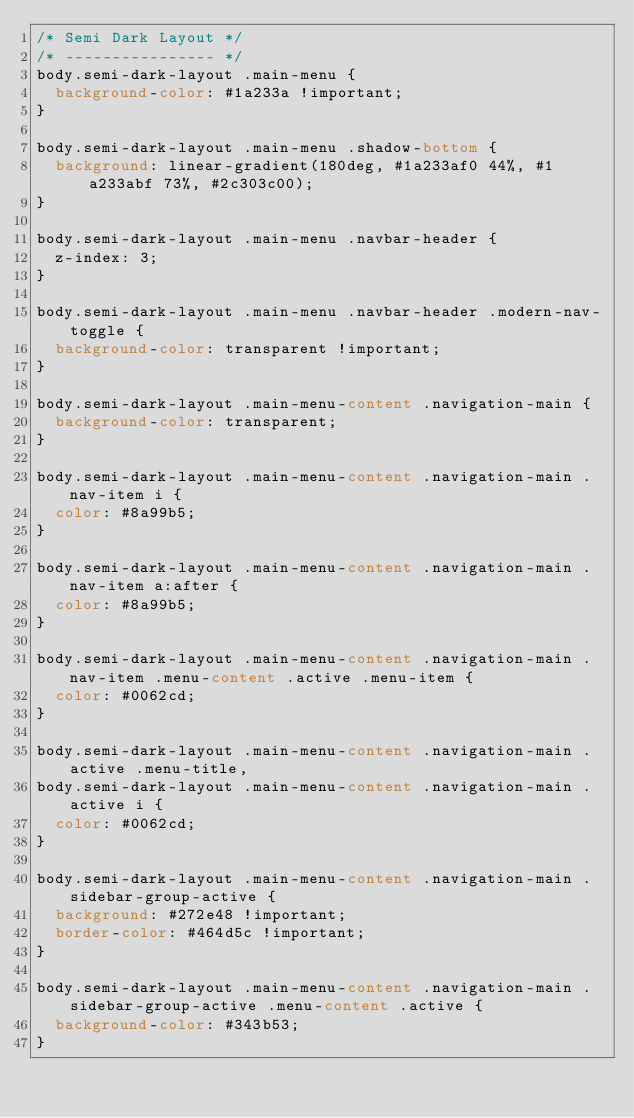Convert code to text. <code><loc_0><loc_0><loc_500><loc_500><_CSS_>/* Semi Dark Layout */
/* ---------------- */
body.semi-dark-layout .main-menu {
  background-color: #1a233a !important;
}

body.semi-dark-layout .main-menu .shadow-bottom {
  background: linear-gradient(180deg, #1a233af0 44%, #1a233abf 73%, #2c303c00);
}

body.semi-dark-layout .main-menu .navbar-header {
  z-index: 3;
}

body.semi-dark-layout .main-menu .navbar-header .modern-nav-toggle {
  background-color: transparent !important;
}

body.semi-dark-layout .main-menu-content .navigation-main {
  background-color: transparent;
}

body.semi-dark-layout .main-menu-content .navigation-main .nav-item i {
  color: #8a99b5;
}

body.semi-dark-layout .main-menu-content .navigation-main .nav-item a:after {
  color: #8a99b5;
}

body.semi-dark-layout .main-menu-content .navigation-main .nav-item .menu-content .active .menu-item {
  color: #0062cd;
}

body.semi-dark-layout .main-menu-content .navigation-main .active .menu-title,
body.semi-dark-layout .main-menu-content .navigation-main .active i {
  color: #0062cd;
}

body.semi-dark-layout .main-menu-content .navigation-main .sidebar-group-active {
  background: #272e48 !important;
  border-color: #464d5c !important;
}

body.semi-dark-layout .main-menu-content .navigation-main .sidebar-group-active .menu-content .active {
  background-color: #343b53;
}
</code> 